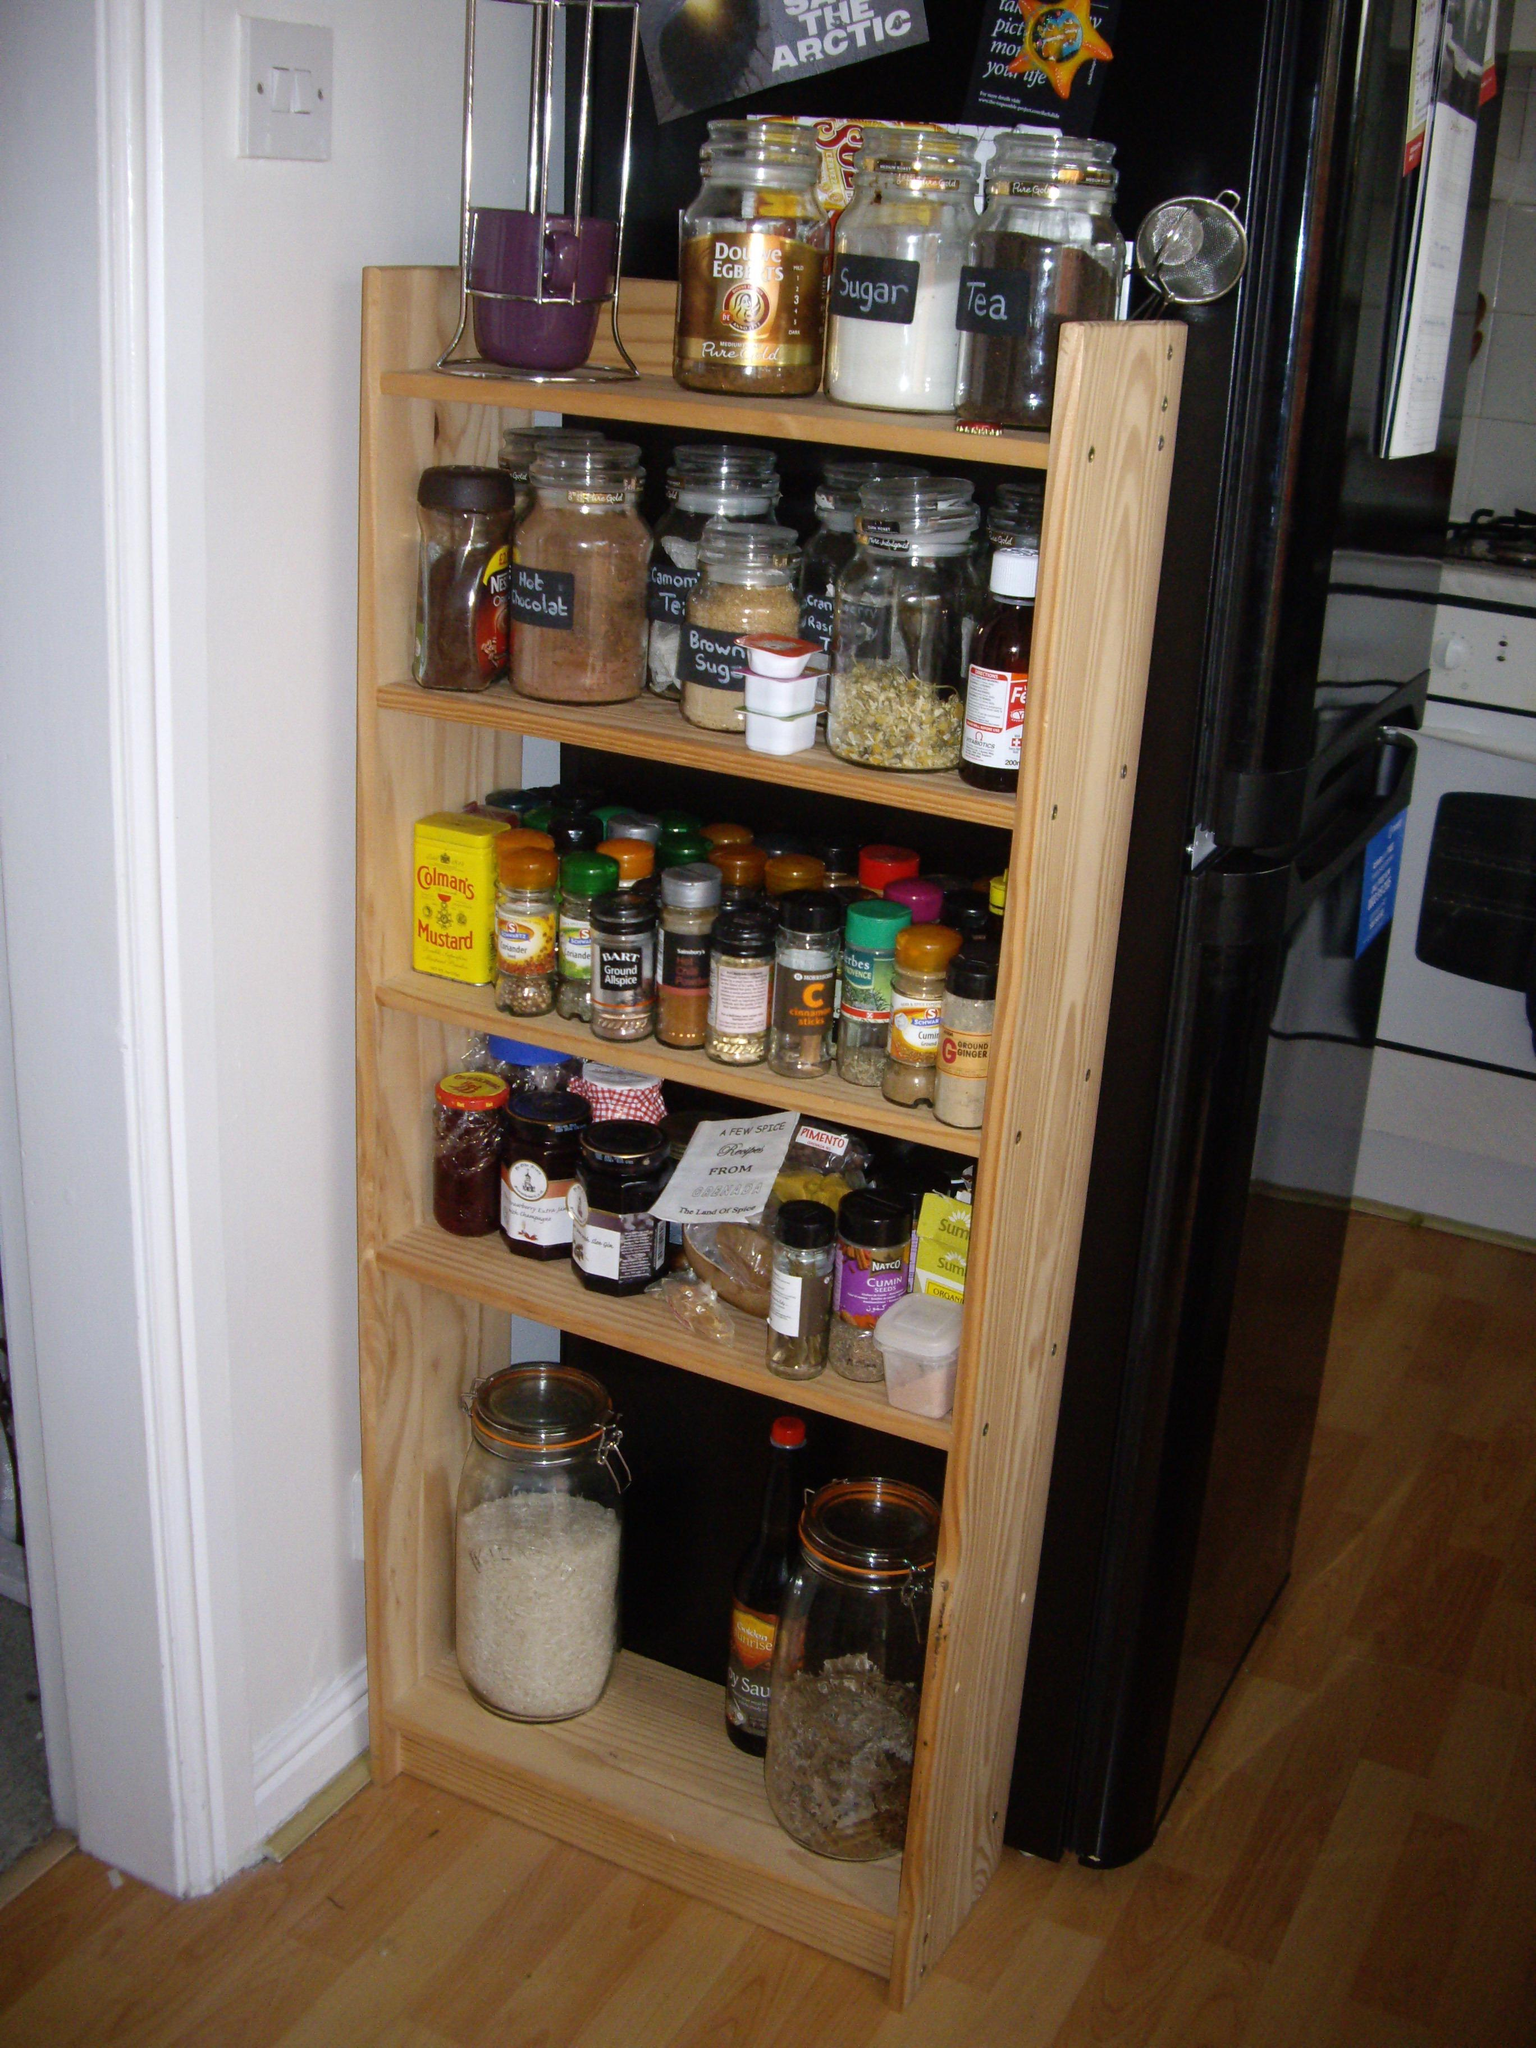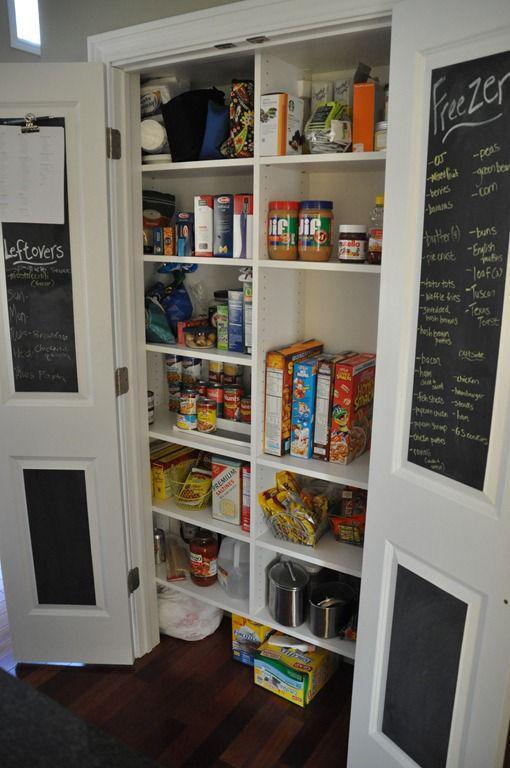The first image is the image on the left, the second image is the image on the right. Considering the images on both sides, is "A lamp is on in one of the images." valid? Answer yes or no. No. The first image is the image on the left, the second image is the image on the right. Evaluate the accuracy of this statement regarding the images: "in at least one image in the middle of a dark wall bookshelf is a wide tv.". Is it true? Answer yes or no. No. 